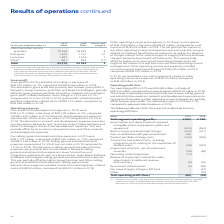According to Nokia Corporation's financial document, What was the rationale for change in operating profit / (loss)? The change in operating result was primarily due to lower selling, general and administrative expenses, research and development expenses and a net positive fluctuation in other operating income and expenses, partially offset by lower gross profit.. The document states: "ed to an operating loss of EUR 59 million in 2018. The change in operating result was primarily due to lower selling, general and administrative expen..." Also, What was the divestment of business in 2019? According to the financial document, (2) (in millions). The relevant text states: "ue and inventory (6) (16) Divestment of businesses (2) (39) Fair value changes of legacy IPR fund – (57) Other – (15) Total operating profit/(loss) 485 (59..." Also, What is excluded from Total segment operating profit? costs related to the acquisition of Alcatel Lucent and related integration, goodwill impairment charges, intangible asset amortization and other purchase price fair value adjustments, restructuring and associated charges and certain other items.. The document states: "(1) Excludes costs related to the acquisition of Alcatel Lucent and related integration, goodwill impairment charges, intangible asset amortization an..." Also, can you calculate: What is the increase / (decrease) in the Total segment operating profit(1) from 2018 to 2019? Based on the calculation: 2,003 - 2,180, the result is -177 (in millions). The key data points involved are: 2,003, 2,180. Also, can you calculate: What is the average Restructuring and associated charges? To answer this question, I need to perform calculations using the financial data. The calculation is: -(502 + 321) / 2, which equals -411.5 (in millions). This is based on the information: "(924) (940) Restructuring and associated charges (502) (321) Gain on defined benefit plan amendment 168 – Product portfolio strategy costs (163) (583) Tr (940) Restructuring and associated charges (50..." The key data points involved are: 321, 502. Also, can you calculate: What percentage of total operating profit / (loss) is Divestment of businesses in 2019? Based on the calculation: (2) / 485, the result is -0.41 (percentage). This is based on the information: "EURm 2019 2018 – (57) Other – (15) Total operating profit/(loss) 485 (59)..." The key data points involved are: 2, 485. 